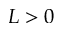Convert formula to latex. <formula><loc_0><loc_0><loc_500><loc_500>L > 0</formula> 